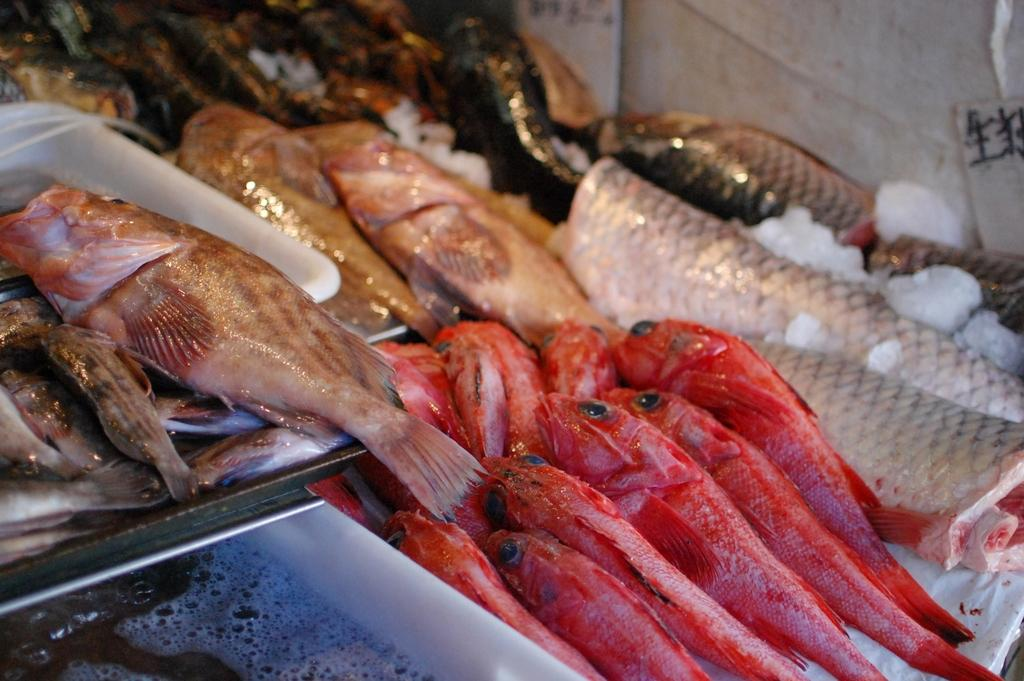What type of animals can be seen in the image? There are different colored fishes in the image. How are the fishes arranged or displayed? Some fishes are on trays in the image. What is the environment in which the fishes are located? There is water and ice visible in the image. What can be seen in the background of the image? There is a wall in the image. What type of company is responsible for the eggnog in the image? There is no eggnog present in the image, so it is not possible to determine which company might be responsible. 